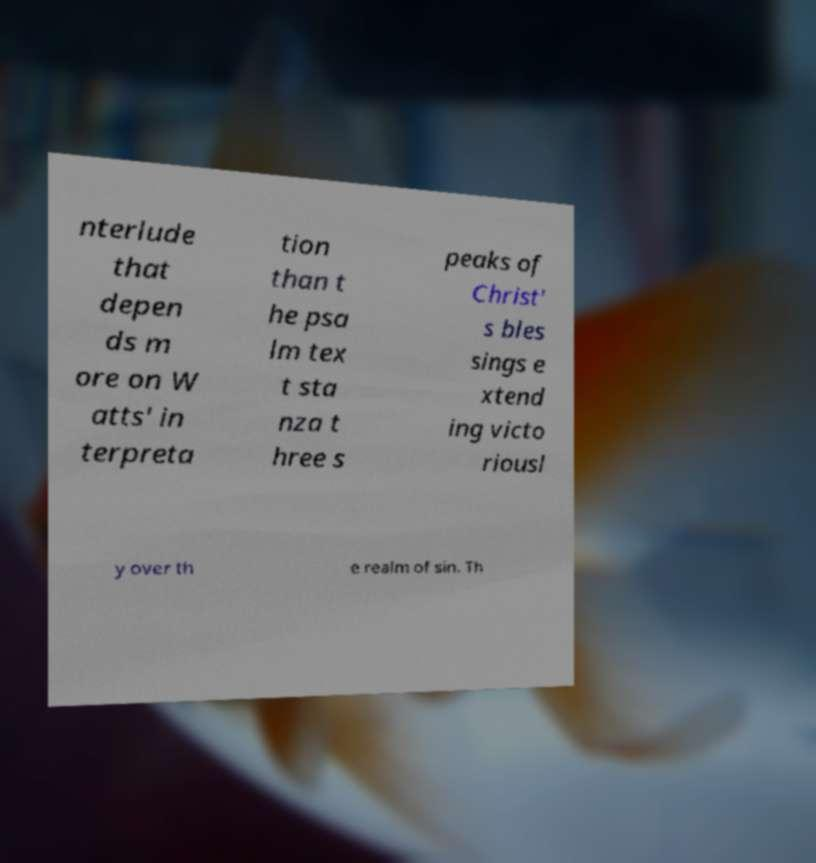For documentation purposes, I need the text within this image transcribed. Could you provide that? nterlude that depen ds m ore on W atts' in terpreta tion than t he psa lm tex t sta nza t hree s peaks of Christ' s bles sings e xtend ing victo riousl y over th e realm of sin. Th 